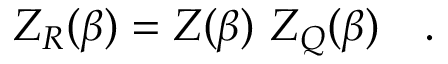<formula> <loc_0><loc_0><loc_500><loc_500>Z _ { R } ( \beta ) = Z ( \beta ) Z _ { Q } ( \beta ) .</formula> 